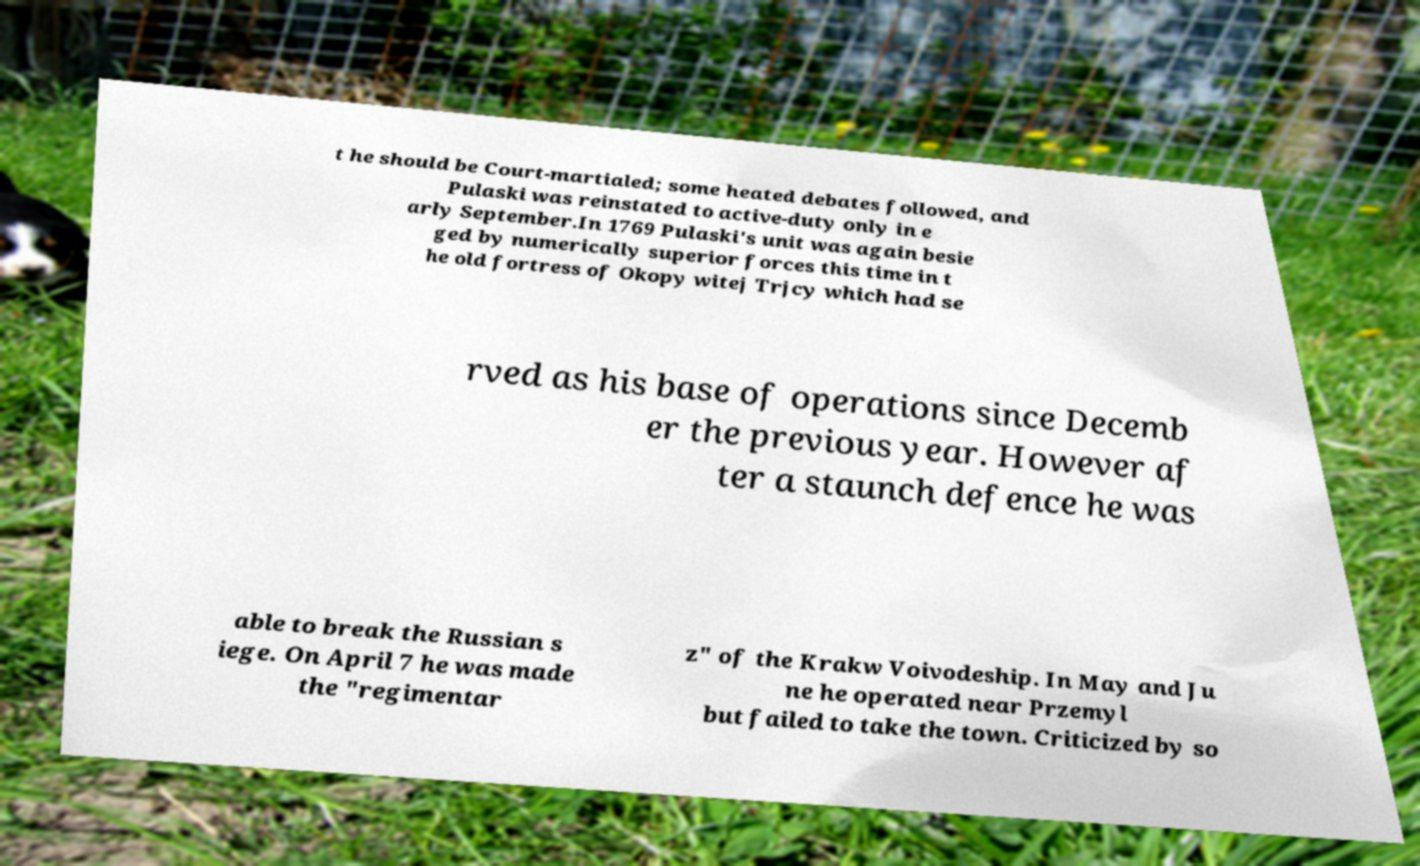Please read and relay the text visible in this image. What does it say? t he should be Court-martialed; some heated debates followed, and Pulaski was reinstated to active-duty only in e arly September.In 1769 Pulaski's unit was again besie ged by numerically superior forces this time in t he old fortress of Okopy witej Trjcy which had se rved as his base of operations since Decemb er the previous year. However af ter a staunch defence he was able to break the Russian s iege. On April 7 he was made the "regimentar z" of the Krakw Voivodeship. In May and Ju ne he operated near Przemyl but failed to take the town. Criticized by so 